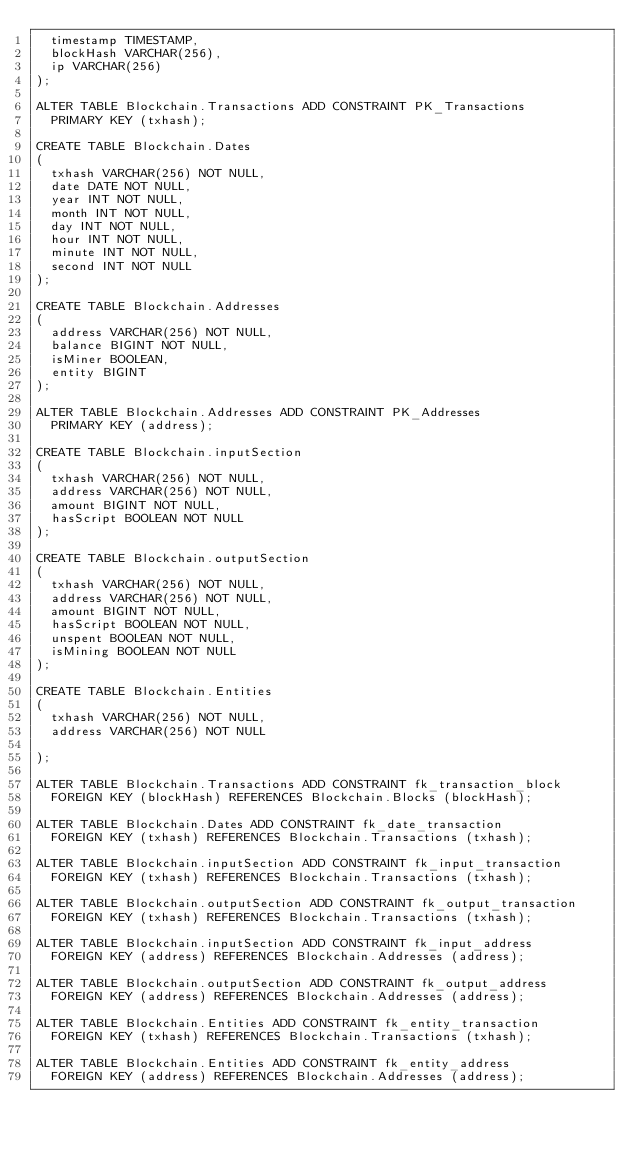<code> <loc_0><loc_0><loc_500><loc_500><_SQL_>  timestamp TIMESTAMP,
  blockHash VARCHAR(256),
  ip VARCHAR(256)
);

ALTER TABLE Blockchain.Transactions ADD CONSTRAINT PK_Transactions
  PRIMARY KEY (txhash);

CREATE TABLE Blockchain.Dates
(
  txhash VARCHAR(256) NOT NULL,
  date DATE NOT NULL,
  year INT NOT NULL,
  month INT NOT NULL,
  day INT NOT NULL,
  hour INT NOT NULL,
  minute INT NOT NULL,
  second INT NOT NULL
);

CREATE TABLE Blockchain.Addresses
(
  address VARCHAR(256) NOT NULL,
  balance BIGINT NOT NULL,
  isMiner BOOLEAN,
  entity BIGINT
);

ALTER TABLE Blockchain.Addresses ADD CONSTRAINT PK_Addresses
  PRIMARY KEY (address);

CREATE TABLE Blockchain.inputSection
(
  txhash VARCHAR(256) NOT NULL,
  address VARCHAR(256) NOT NULL,
  amount BIGINT NOT NULL,
  hasScript BOOLEAN NOT NULL
);

CREATE TABLE Blockchain.outputSection
(
  txhash VARCHAR(256) NOT NULL,
  address VARCHAR(256) NOT NULL,
  amount BIGINT NOT NULL,
  hasScript BOOLEAN NOT NULL,
  unspent BOOLEAN NOT NULL,
  isMining BOOLEAN NOT NULL
);

CREATE TABLE Blockchain.Entities
(
  txhash VARCHAR(256) NOT NULL,
  address VARCHAR(256) NOT NULL
 
);

ALTER TABLE Blockchain.Transactions ADD CONSTRAINT fk_transaction_block
  FOREIGN KEY (blockHash) REFERENCES Blockchain.Blocks (blockHash);

ALTER TABLE Blockchain.Dates ADD CONSTRAINT fk_date_transaction
  FOREIGN KEY (txhash) REFERENCES Blockchain.Transactions (txhash);

ALTER TABLE Blockchain.inputSection ADD CONSTRAINT fk_input_transaction
  FOREIGN KEY (txhash) REFERENCES Blockchain.Transactions (txhash);

ALTER TABLE Blockchain.outputSection ADD CONSTRAINT fk_output_transaction
  FOREIGN KEY (txhash) REFERENCES Blockchain.Transactions (txhash);
  
ALTER TABLE Blockchain.inputSection ADD CONSTRAINT fk_input_address
  FOREIGN KEY (address) REFERENCES Blockchain.Addresses (address);

ALTER TABLE Blockchain.outputSection ADD CONSTRAINT fk_output_address
  FOREIGN KEY (address) REFERENCES Blockchain.Addresses (address);
  
ALTER TABLE Blockchain.Entities ADD CONSTRAINT fk_entity_transaction
  FOREIGN KEY (txhash) REFERENCES Blockchain.Transactions (txhash); 
 
ALTER TABLE Blockchain.Entities ADD CONSTRAINT fk_entity_address
  FOREIGN KEY (address) REFERENCES Blockchain.Addresses (address);</code> 